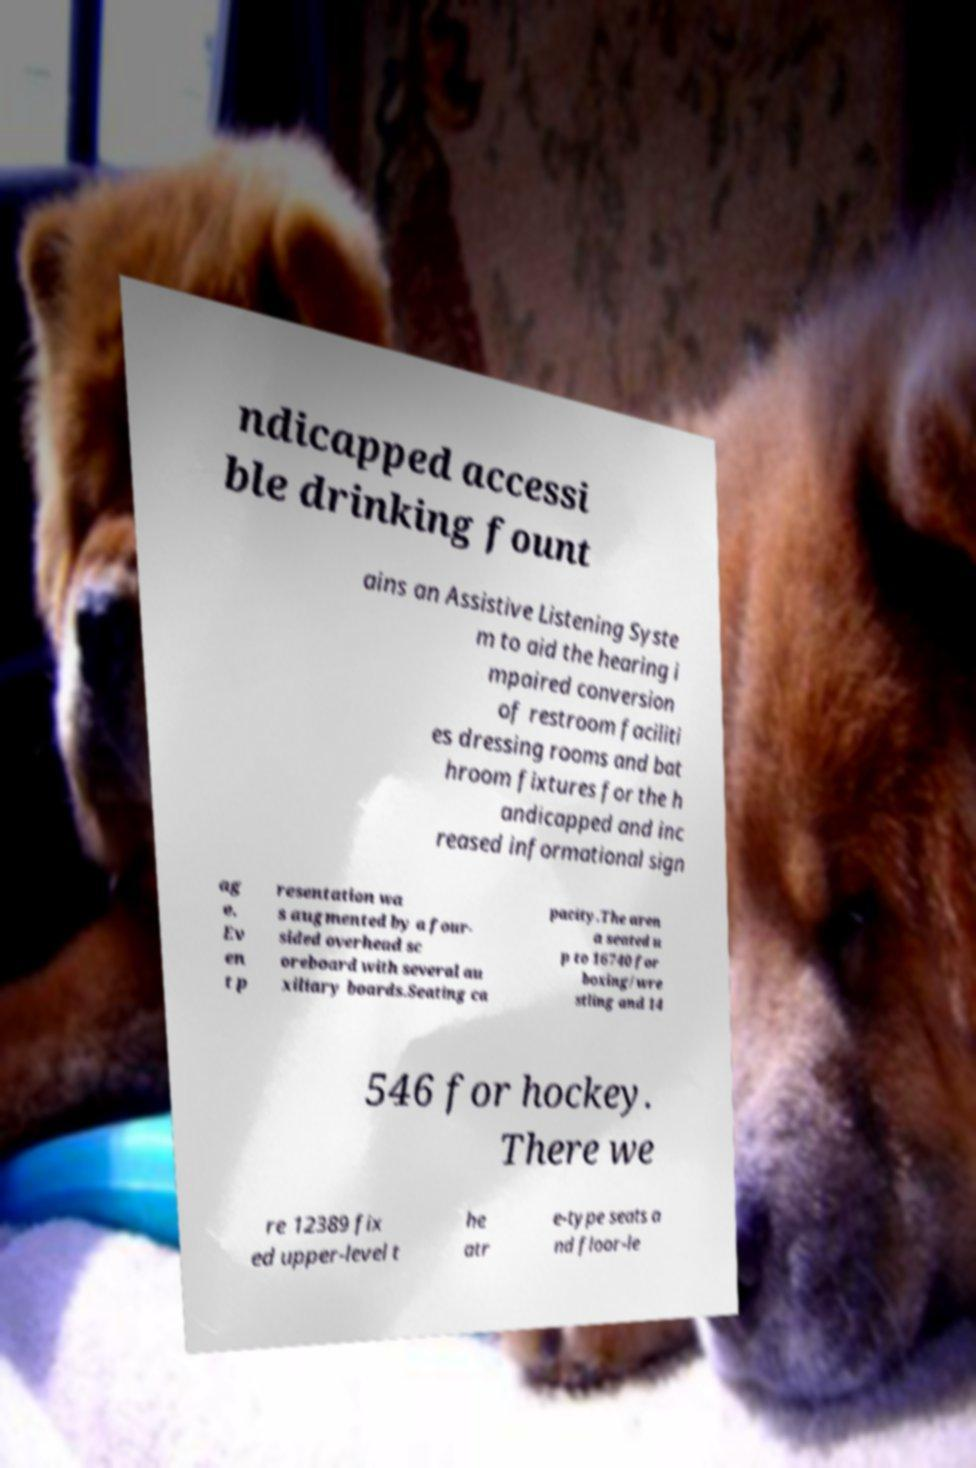There's text embedded in this image that I need extracted. Can you transcribe it verbatim? ndicapped accessi ble drinking fount ains an Assistive Listening Syste m to aid the hearing i mpaired conversion of restroom faciliti es dressing rooms and bat hroom fixtures for the h andicapped and inc reased informational sign ag e. Ev en t p resentation wa s augmented by a four- sided overhead sc oreboard with several au xiliary boards.Seating ca pacity.The aren a seated u p to 16740 for boxing/wre stling and 14 546 for hockey. There we re 12389 fix ed upper-level t he atr e-type seats a nd floor-le 